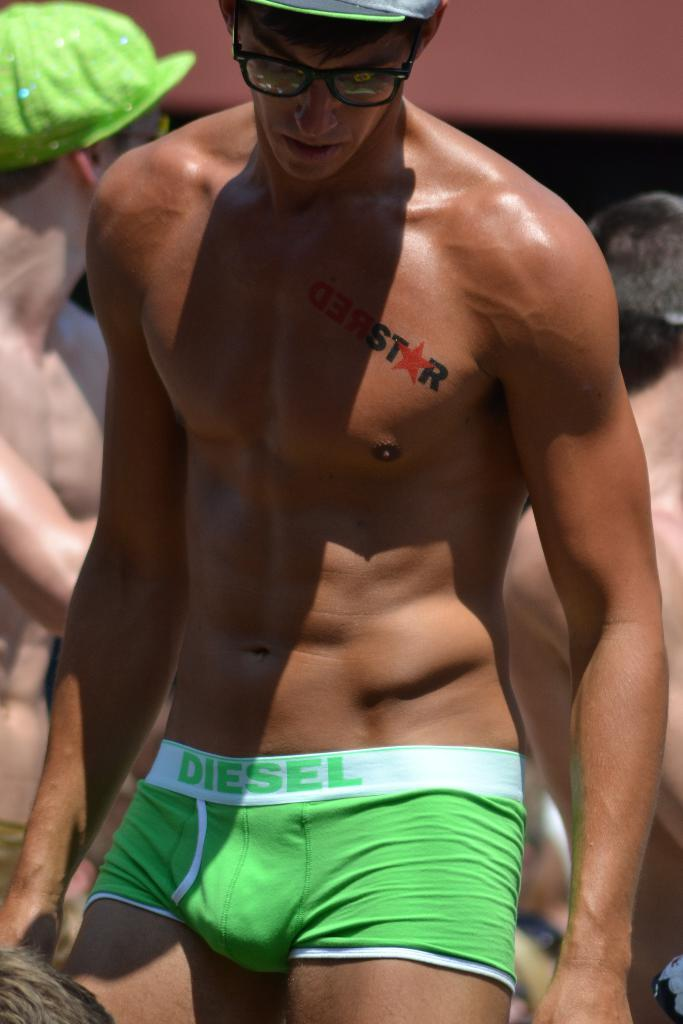<image>
Present a compact description of the photo's key features. An athletic looking man is shirtless and wearing neon green Diesel boxers. 